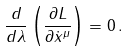<formula> <loc_0><loc_0><loc_500><loc_500>\frac { d } { d \lambda } \left ( \frac { \partial L } { \partial \dot { x } ^ { \mu } } \right ) = 0 \, .</formula> 